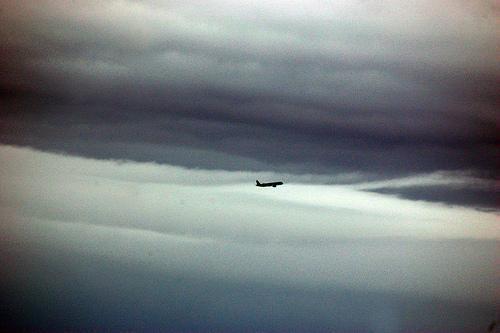How many airplanes are there?
Give a very brief answer. 1. How many tails does the airplane have?
Give a very brief answer. 1. 